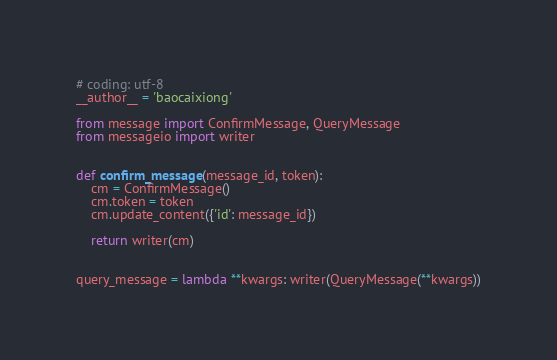Convert code to text. <code><loc_0><loc_0><loc_500><loc_500><_Python_># coding: utf-8
__author__ = 'baocaixiong'

from message import ConfirmMessage, QueryMessage
from messageio import writer


def confirm_message(message_id, token):
    cm = ConfirmMessage()
    cm.token = token
    cm.update_content({'id': message_id})

    return writer(cm)


query_message = lambda **kwargs: writer(QueryMessage(**kwargs))
</code> 